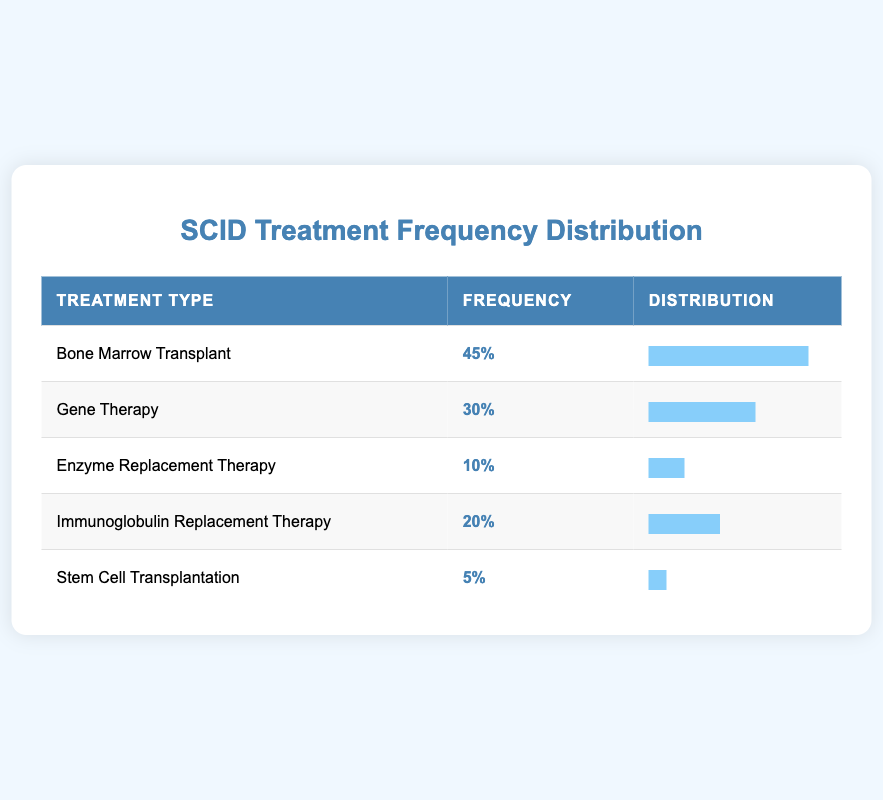What treatment type has the highest frequency among SCID patients? The table lists the treatment types with their corresponding frequencies. By examining the "Frequency" column, Bone Marrow Transplant has the highest frequency at 45.
Answer: Bone Marrow Transplant How many patients received Gene Therapy? The frequency of patients who received Gene Therapy is explicitly stated in the table. It shows a frequency of 30.
Answer: 30 Is there a treatment option that was received by less than 10 percent of patients? To determine this, we need to look at the frequencies in the table. Stem Cell Transplantation has a frequency of 5, which is less than 10 percent.
Answer: Yes What is the total number of treatments received by the patients listed in the table? We will sum up the frequencies from each treatment type: 45 + 30 + 10 + 20 + 5 = 110. Hence, the total number of treatments is 110.
Answer: 110 What percentage of patients received Immunoglobulin Replacement Therapy compared to those receiving Bone Marrow Transplant? The frequency for Immunoglobulin Replacement Therapy is 20, while Bone Marrow Transplant is 45. The percentage is calculated as (20 / 45) * 100, which equals approximately 44.44 percent.
Answer: 44.44 percent Which treatment type had the lowest frequency among SCID patients? Looking at the frequencies, Stem Cell Transplantation has the lowest frequency at 5.
Answer: Stem Cell Transplantation How many more patients received Bone Marrow Transplant than Enzyme Replacement Therapy? From the table, Bone Marrow Transplant has a frequency of 45 and Enzyme Replacement Therapy has a frequency of 10. The difference is calculated as 45 - 10 = 35.
Answer: 35 What is the average frequency of treatments received by SCID patients? To find the average, we total the frequencies (110 from previous calculation) and divide by the number of treatment types, which is 5. Hence, the average is 110 / 5 = 22.
Answer: 22 Is the frequency of Enzyme Replacement Therapy equal to that of Stem Cell Transplantation? Comparing the frequencies from the table, Enzyme Replacement Therapy has a frequency of 10 and Stem Cell Transplantation has a frequency of 5; therefore, they are not equal.
Answer: No What is the total frequency of Gene Therapy and Immunoglobulin Replacement Therapy combined? The frequency for Gene Therapy is 30 and for Immunoglobulin Replacement Therapy is 20. Adding these frequencies gives us 30 + 20 = 50.
Answer: 50 